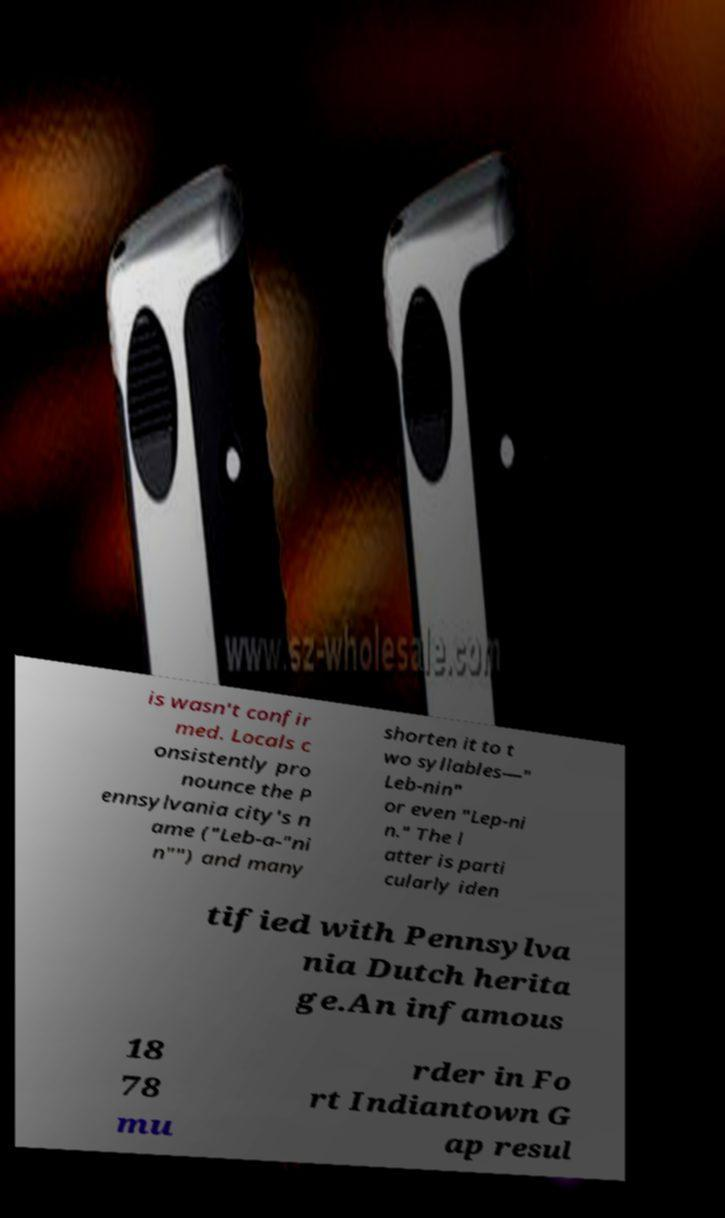I need the written content from this picture converted into text. Can you do that? is wasn't confir med. Locals c onsistently pro nounce the P ennsylvania city's n ame ("Leb-a-"ni n"") and many shorten it to t wo syllables—" Leb-nin" or even "Lep-ni n." The l atter is parti cularly iden tified with Pennsylva nia Dutch herita ge.An infamous 18 78 mu rder in Fo rt Indiantown G ap resul 